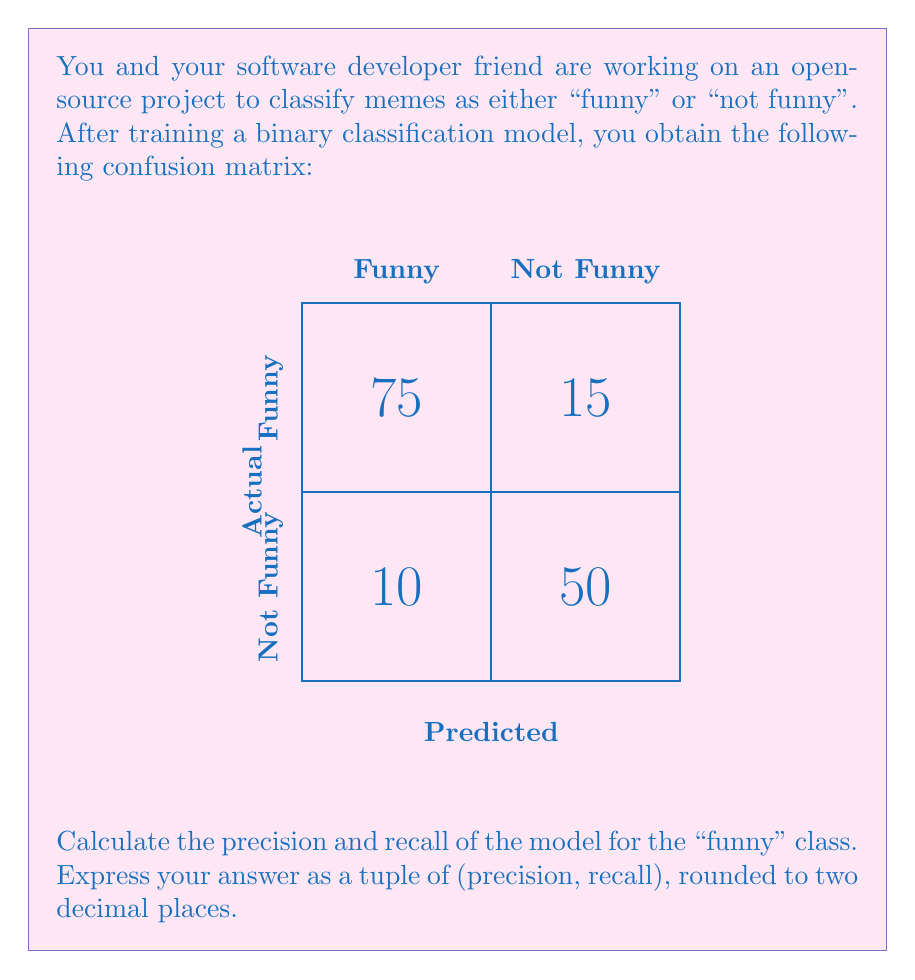Show me your answer to this math problem. Let's approach this step-by-step:

1) First, let's identify the components of the confusion matrix:
   - True Positives (TP) = 75 (correctly classified as funny)
   - False Positives (FP) = 10 (incorrectly classified as funny)
   - False Negatives (FN) = 15 (incorrectly classified as not funny)
   - True Negatives (TN) = 50 (correctly classified as not funny)

2) Precision is defined as:
   $$ \text{Precision} = \frac{\text{TP}}{\text{TP} + \text{FP}} $$

   Substituting our values:
   $$ \text{Precision} = \frac{75}{75 + 10} = \frac{75}{85} \approx 0.8824 $$

3) Recall is defined as:
   $$ \text{Recall} = \frac{\text{TP}}{\text{TP} + \text{FN}} $$

   Substituting our values:
   $$ \text{Recall} = \frac{75}{75 + 15} = \frac{75}{90} \approx 0.8333 $$

4) Rounding both values to two decimal places:
   - Precision ≈ 0.88
   - Recall ≈ 0.83

5) Expressing the answer as a tuple: (0.88, 0.83)
Answer: (0.88, 0.83) 